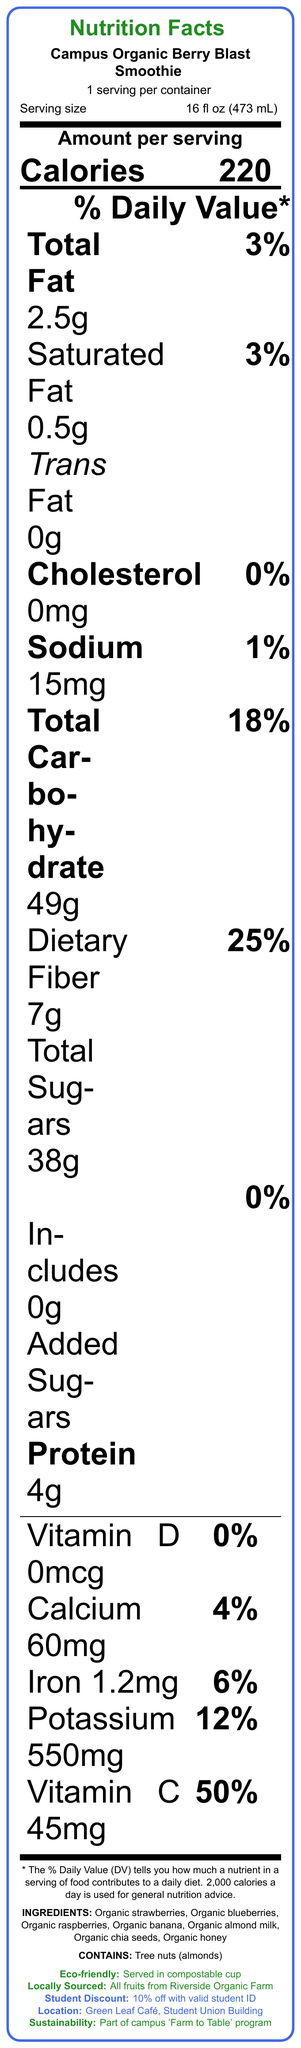what is the serving size of the Campus Organic Berry Blast Smoothie? The serving size is listed right below the product name on the document, which states "Serving size 16 fl oz (473 mL)".
Answer: 16 fl oz (473 mL) how many calories are in one serving? The calories per serving are prominently displayed in bold as "Calories 220" under the heading "Amount per serving".
Answer: 220 what is the amount of total dietary fiber in the smoothie? The amount of dietary fiber is listed under the "Total Carbohydrate" section, specifically stating "Dietary Fiber 7g".
Answer: 7g does the smoothie contain any added sugars? The document specifies "Includes 0g Added Sugars", indicating there are no added sugars in the smoothie.
Answer: No where are the fruits for the smoothie sourced from? The document has an eco-friendly note that states "All fruits sourced from Riverside Organic Farm".
Answer: Riverside Organic Farm what percentage of the daily value of Vitamin C does this smoothie provide? The percentage is mentioned under the vitamin and mineral section with "Vitamin C 45mg" followed by "50%".
Answer: 50% which allergen is contained in the smoothie? The presence of tree nuts is indicated under the allergens section with "CONTAINS: Tree nuts (almonds)".
Answer: Tree nuts (almonds) how much protein does one serving of the Campus Organic Berry Blast Smoothie contain? The amount of protein is listed in the nutritional information section as "Protein 4g".
Answer: 4g what is the sodium content per serving? The sodium content per serving is stated in the nutritional information with "Sodium 15mg".
Answer: 15mg how many different organic fruits are used in the smoothie ingredients? The ingredients list shows four organic fruits: strawberries, blueberries, raspberries, and banana.
Answer: 4 what is special about the cups used for serving the smoothie? A. Recyclable B. Compostable C. Made from glass D. Biodegradable The document mentions "Served in compostable cup made from plant-based materials" under the eco-friendly note.
Answer: B what discount can students get with a valid student ID? A. 5% B. 10% C. 15% D. 20% The document specifies "Student Discount: 10% off with valid student ID" in the additional information section.
Answer: B is this smoothie part of a sustainability initiative on campus? The document clearly states "Part of the campus 'Farm to Table' program" under the sustainability initiative.
Answer: Yes is there any information about the opening hours of the cafe? The document does not provide any details on the opening hours of the café.
Answer: Not enough information where is the cafe that serves this smoothie located? The document specifies the location as "Green Leaf Café, Student Union Building" under the additional info section.
Answer: Green Leaf Café, Student Union Building can you summarize the main idea of the document? The document primarily serves to inform about the nutrition facts and sourcing of the Campus Organic Berry Blast Smoothie, emphasizing its organic and locally sourced ingredients, as well as its alignment with the campus's ecological and sustainability goals.
Answer: The document provides detailed nutrition facts and additional information for the Campus Organic Berry Blast Smoothie, which is a locally-sourced, organic fruit smoothie sold at the Green Leaf Café in the Student Union Building. It highlights nutritional content, ingredients, allergens, and eco-friendly practices, along with a student discount and its connection to the campus 'Farm to Table' program. 